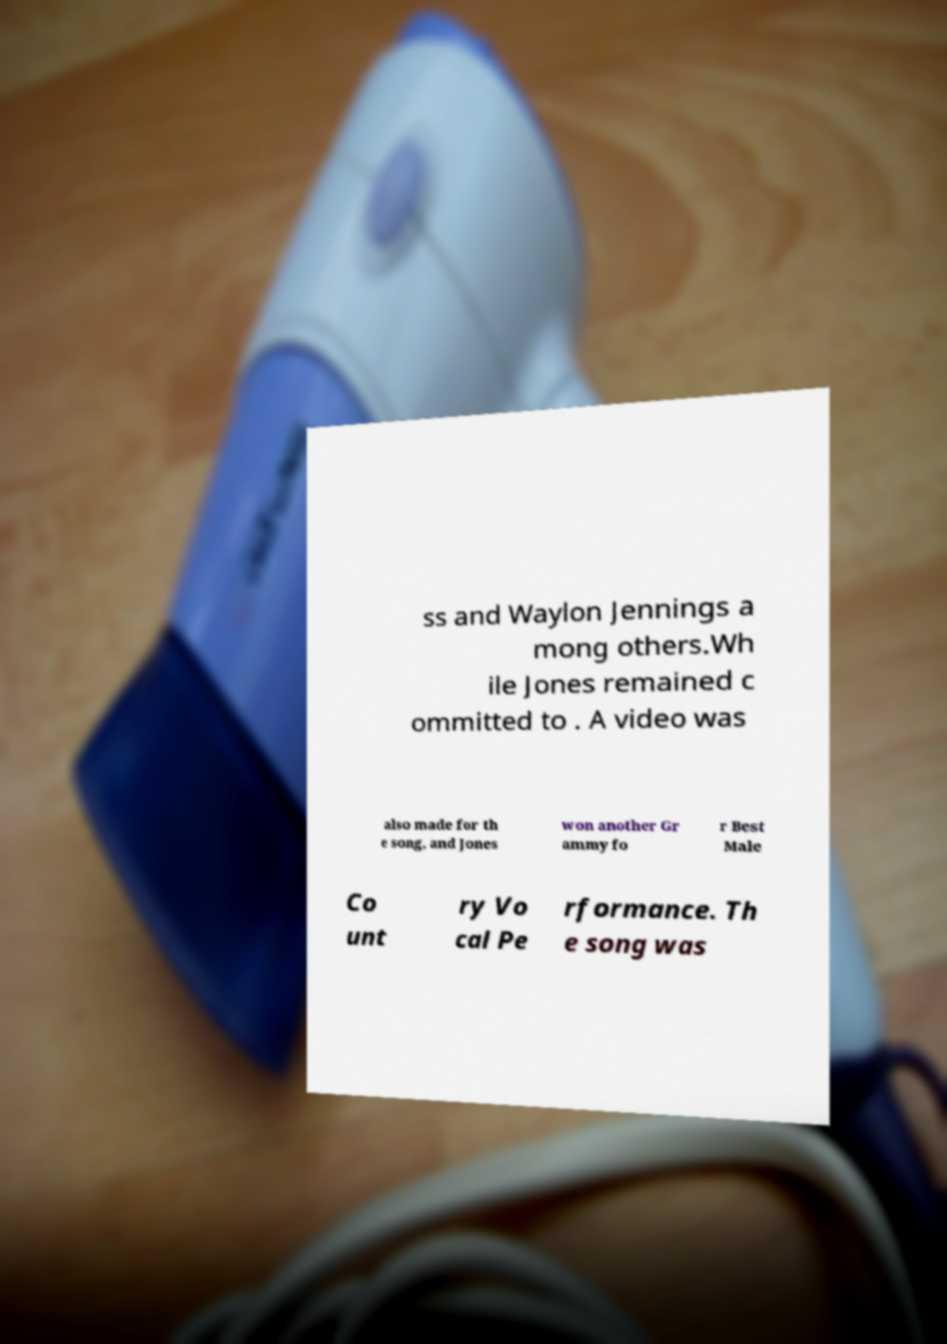Please identify and transcribe the text found in this image. ss and Waylon Jennings a mong others.Wh ile Jones remained c ommitted to . A video was also made for th e song, and Jones won another Gr ammy fo r Best Male Co unt ry Vo cal Pe rformance. Th e song was 